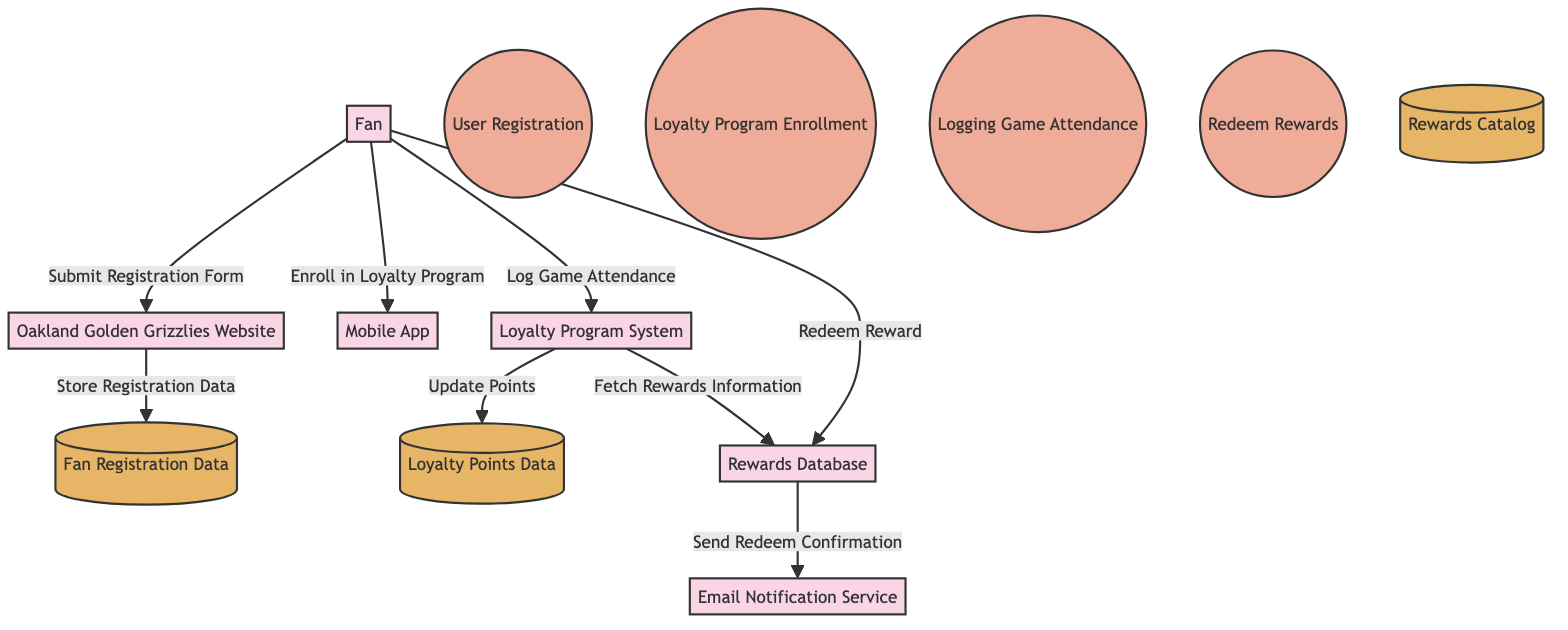What is the first process for fan engagement? The first process depicted in the diagram is the "User Registration" process as it is directly connected to the Fan entity at the top of the flow.
Answer: User Registration How many entities are present in the diagram? By counting the entity nodes in the diagram, we see there are 6 entities, including Fan, Oakland Golden Grizzlies Website, Loyalty Program System, Rewards Database, Email Notification Service, and Mobile App.
Answer: 6 What data store holds loyalty points? The "Loyalty Points Data" data store specifically contains information regarding fans' loyalty points and their accrual, as indicated in the data store section of the diagram.
Answer: Loyalty Points Data What action does the fan perform to redeem rewards? The action performed by the fan to redeem rewards is a direct flow labeled "Redeem Reward," which connects the Fan entity to the Rewards Database entity.
Answer: Redeem Reward Which service sends notifications to fans upon reward redemption? The "Email Notification Service" is responsible for sending notifications, specifically the confirmation of reward redemption from the Rewards Database to the fan.
Answer: Email Notification Service What process is responsible for logging game attendance? The process that captures a fan's attendance at games is called "Logging Game Attendance," which flows from the Fan entity to the Loyalty Program System.
Answer: Logging Game Attendance How many data stores are utilized in the diagram? There are three data stores highlighted in the diagram, those being Fan Registration Data, Loyalty Points Data, and Rewards Catalog.
Answer: 3 What initiates the flow of fan registration data? The flow is initiated when the Fan submits the registration form to the Oakland Golden Grizzlies Website, facilitating the connection and leading to the storage of registration data.
Answer: Submit Registration Form Where do fans enroll in the loyalty program? Fans can enroll in the loyalty program through the Mobile App as indicated by the flow from Fan to Mobile App labeled "Enroll in Loyalty Program."
Answer: Mobile App 